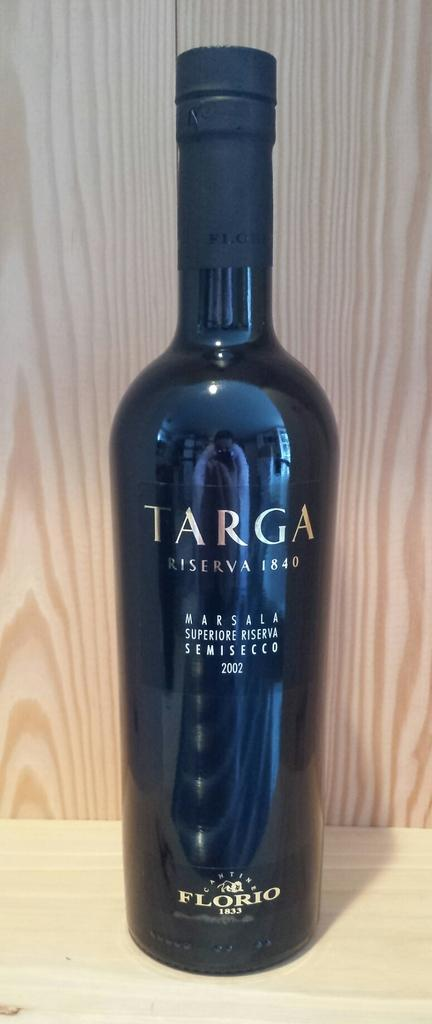Provide a one-sentence caption for the provided image. Long bottle of Targa wine from the year 1840. 